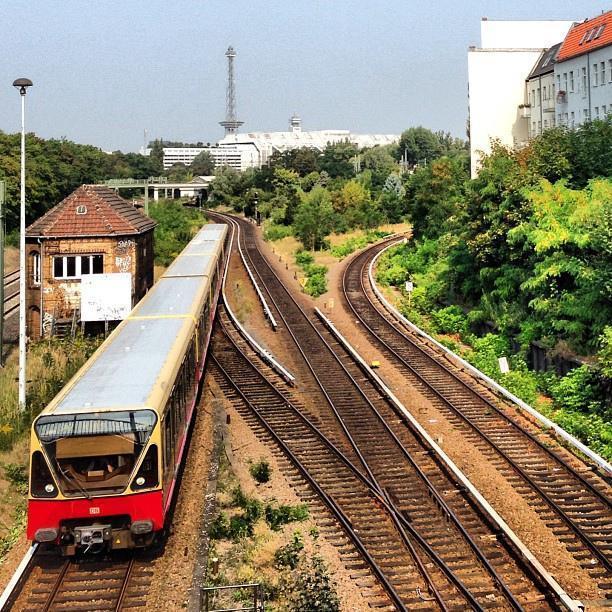How many trains are there?
Give a very brief answer. 1. 